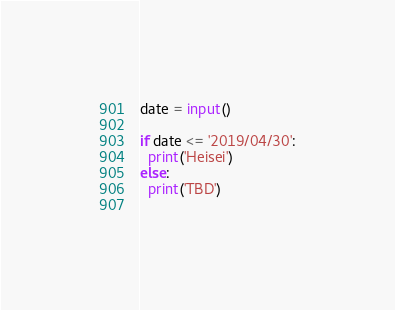Convert code to text. <code><loc_0><loc_0><loc_500><loc_500><_Python_>date = input()

if date <= '2019/04/30':
  print('Heisei')
else:
  print('TBD')
    </code> 